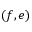<formula> <loc_0><loc_0><loc_500><loc_500>( f , e )</formula> 